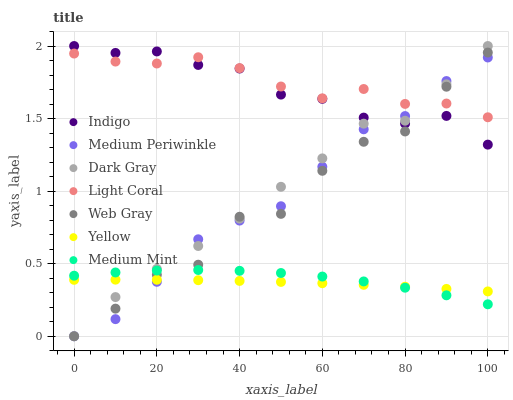Does Yellow have the minimum area under the curve?
Answer yes or no. Yes. Does Light Coral have the maximum area under the curve?
Answer yes or no. Yes. Does Web Gray have the minimum area under the curve?
Answer yes or no. No. Does Web Gray have the maximum area under the curve?
Answer yes or no. No. Is Yellow the smoothest?
Answer yes or no. Yes. Is Web Gray the roughest?
Answer yes or no. Yes. Is Light Coral the smoothest?
Answer yes or no. No. Is Light Coral the roughest?
Answer yes or no. No. Does Web Gray have the lowest value?
Answer yes or no. Yes. Does Light Coral have the lowest value?
Answer yes or no. No. Does Dark Gray have the highest value?
Answer yes or no. Yes. Does Light Coral have the highest value?
Answer yes or no. No. Is Yellow less than Light Coral?
Answer yes or no. Yes. Is Indigo greater than Yellow?
Answer yes or no. Yes. Does Web Gray intersect Indigo?
Answer yes or no. Yes. Is Web Gray less than Indigo?
Answer yes or no. No. Is Web Gray greater than Indigo?
Answer yes or no. No. Does Yellow intersect Light Coral?
Answer yes or no. No. 